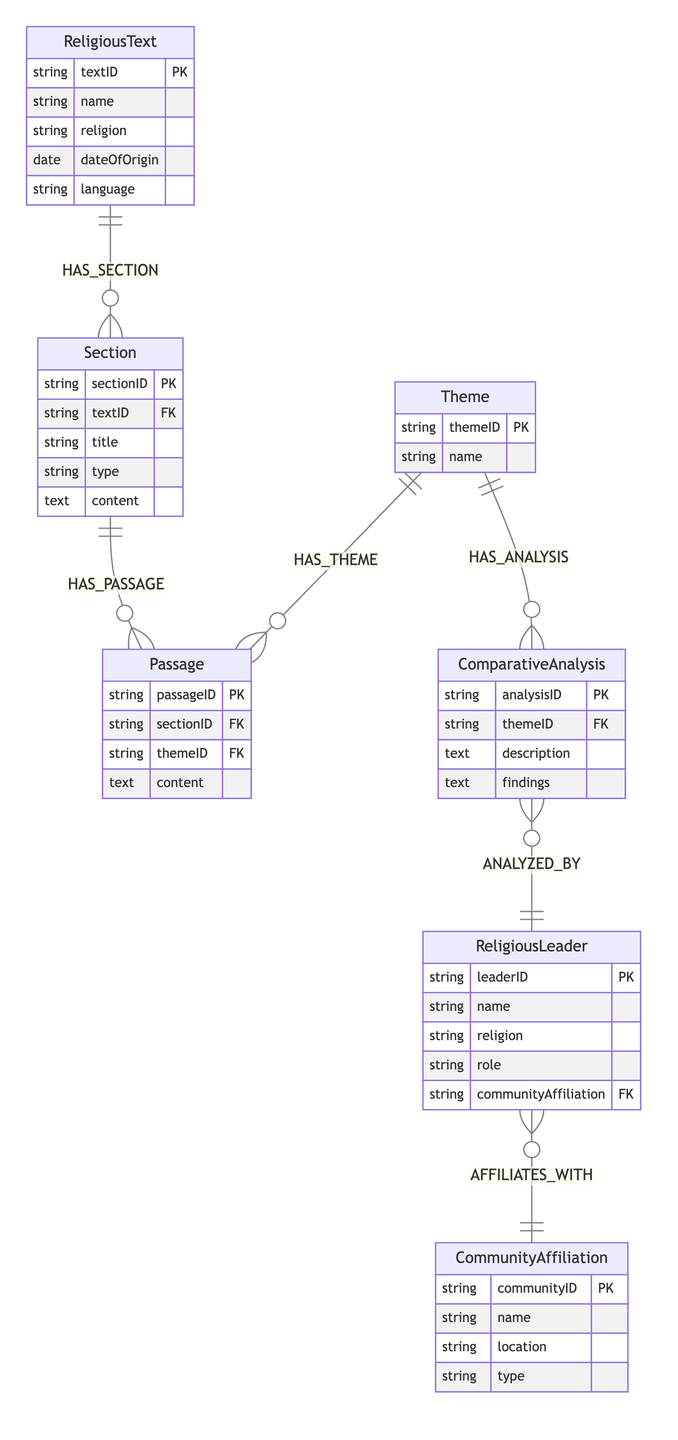What is the primary entity in this diagram? The primary entity is the 'ReligiousText'. It is the main starting point of the diagram and the foundational piece that contains other related entities such as sections, themes, and passages.
Answer: ReligiousText How many relationships exist in the diagram? The diagram shows a total of 6 relationships: HAS_SECTION, HAS_PASSAGE, HAS_THEME, HAS_ANALYSIS, ANALYZED_BY, and AFFILIATES_WITH. Each relationship connects two entities and illustrates how they interact with each other.
Answer: 6 Which entity is directly connected to ComparativeAnalysis? The 'ReligiousLeader' entity is directly connected to the 'ComparativeAnalysis' entity through the relationship 'ANALYZED_BY'. This indicates that the analysis is attributed to a specific religious leader.
Answer: ReligiousLeader What type of relationship is HAS_THEME? The relationship 'HAS_THEME' signifies that a 'Theme' can be linked to multiple 'Passages'. It indicates that the essence or subject of each theme can be expressed through various passages in religious texts.
Answer: One-to-Many How many attributes does the ReligiousText entity have? The 'ReligiousText' entity has 5 attributes: textID, name, religion, dateOfOrigin, and language. These attributes provide information about the religious texts themselves.
Answer: 5 Which entity has a many-to-one relationship with Section? The 'Section' entity has a many-to-one relationship with 'ReligiousText'. This means that each section belongs to only one religious text, but a religious text can have multiple sections associated with it.
Answer: ReligiousText What is the nature of the connection between Theme and Passage? The connection between 'Theme' and 'Passage' is a one-to-many relationship as indicated by the 'HAS_THEME' relationship, which shows that a single theme can relate to multiple passages across various sections of texts.
Answer: One-to-Many How is a CommunityAffiliation related to ReligiousLeader? The 'CommunityAffiliation' is related to 'ReligiousLeader' through the relationship 'AFFILIATES_WITH', indicating that a religious leader is affiliated with a specific community.
Answer: Affiliation What does ComparativeAnalysis analyze? The 'ComparativeAnalysis' analyzes 'Theme', as shown by the 'HAS_ANALYSIS' relationship. This implies that the analysis provided is based on themes drawn from the religious passages.
Answer: Theme 